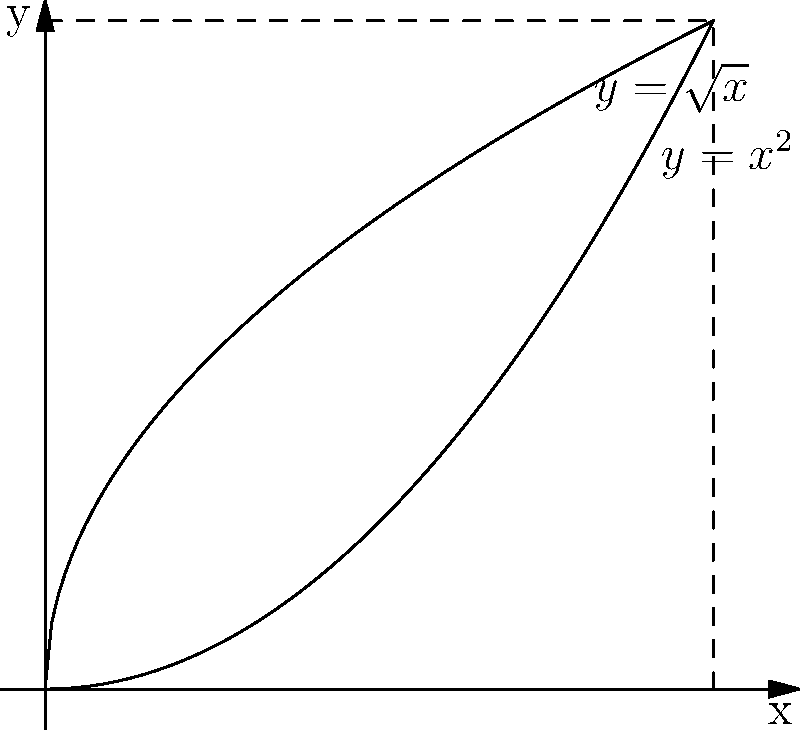Consider the solid formed by rotating the region bounded by $y=\sqrt{x}$, $y=x^2$, and the y-axis about the y-axis. Using the shell method, set up (but do not evaluate) the integral that represents the volume of this solid of revolution. To set up the integral using the shell method, we follow these steps:

1) In the shell method, we integrate with respect to y. The limits of integration will be from the lowest to the highest y-value in the region.

2) The lowest y-value is 0, and the highest is where the two functions intersect. To find this, we set $\sqrt{x} = x^2$:
   
   $x = x^4$
   $x - x^4 = 0$
   $x(1 - x^3) = 0$
   $x = 0$ or $x = 1$

   Since $x = 0$ is the y-axis, the intersection point is at $(1,1)$.

3) For each y-value, we need to find the inner and outer radii of the shell. These are the x-values of the bounding curves:
   
   Inner radius: $r_i = y^2$ (solving $y = \sqrt{x}$ for x)
   Outer radius: $r_o = \sqrt{y}$ (solving $y = x^2$ for x)

4) The volume of each shell is given by $2\pi x h dy$, where x is the average radius and h is the height of the shell:
   
   $x = \frac{r_o + r_i}{2} = \frac{\sqrt{y} + y^2}{2}$
   $h = r_o - r_i = \sqrt{y} - y^2$

5) Putting it all together, the integral is:

   $$V = 2\pi \int_0^1 \frac{\sqrt{y} + y^2}{2} (\sqrt{y} - y^2) dy$$

This sets up the integral for the volume of the solid of revolution using the shell method.
Answer: $$V = 2\pi \int_0^1 \frac{\sqrt{y} + y^2}{2} (\sqrt{y} - y^2) dy$$ 